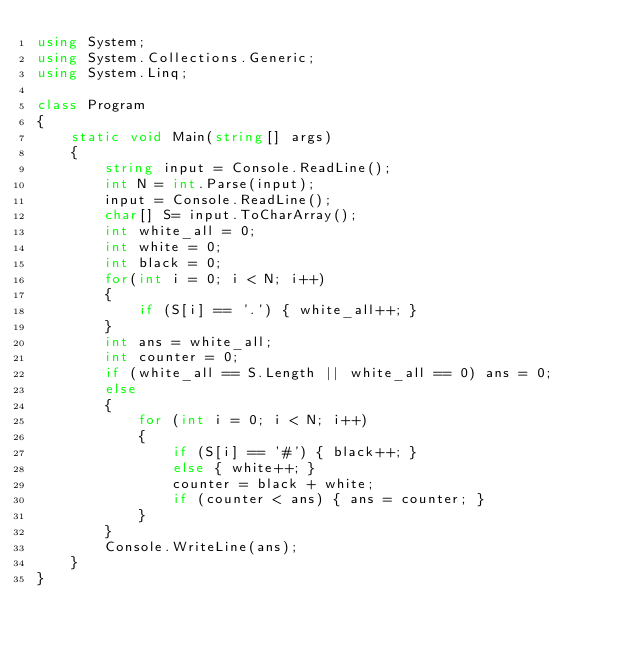Convert code to text. <code><loc_0><loc_0><loc_500><loc_500><_C#_>using System;
using System.Collections.Generic;
using System.Linq;

class Program
{
    static void Main(string[] args)
    {
        string input = Console.ReadLine();
        int N = int.Parse(input);
        input = Console.ReadLine();
        char[] S= input.ToCharArray();
        int white_all = 0;
        int white = 0;
        int black = 0;
        for(int i = 0; i < N; i++)
        {
            if (S[i] == '.') { white_all++; }
        }
        int ans = white_all;
        int counter = 0;
        if (white_all == S.Length || white_all == 0) ans = 0;
        else
        {
            for (int i = 0; i < N; i++)
            {
                if (S[i] == '#') { black++; }
                else { white++; }
                counter = black + white;
                if (counter < ans) { ans = counter; }
            }
        }
        Console.WriteLine(ans);
    }
}</code> 